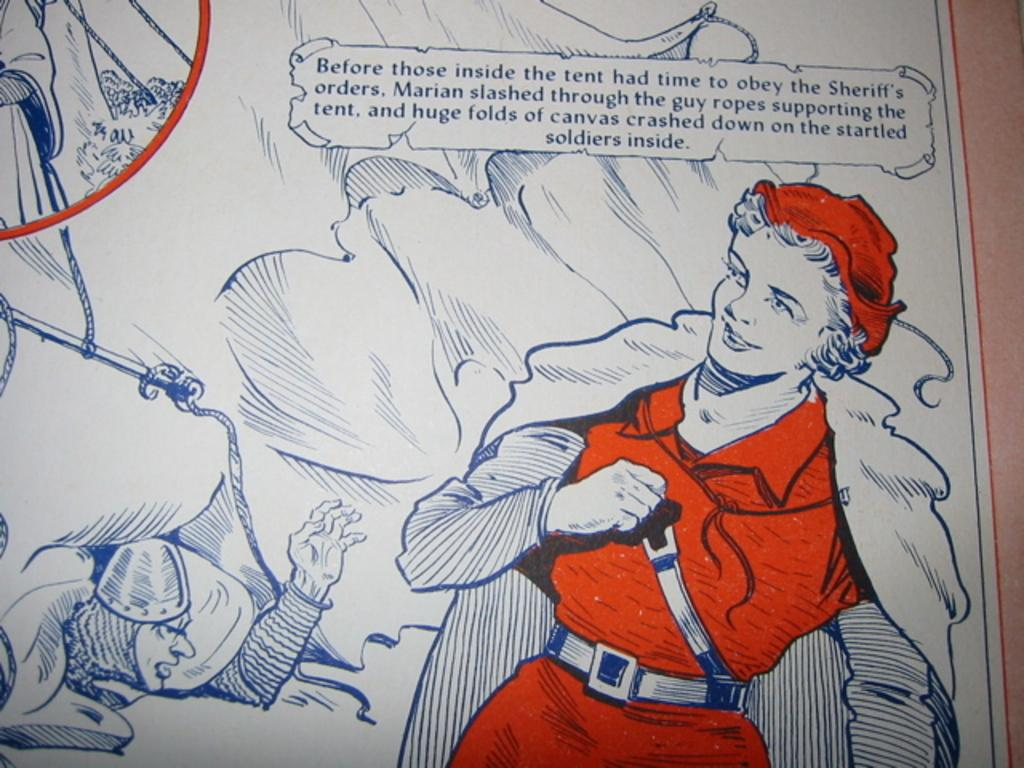<image>
Present a compact description of the photo's key features. The lady here called Marian slashed through the tent. 